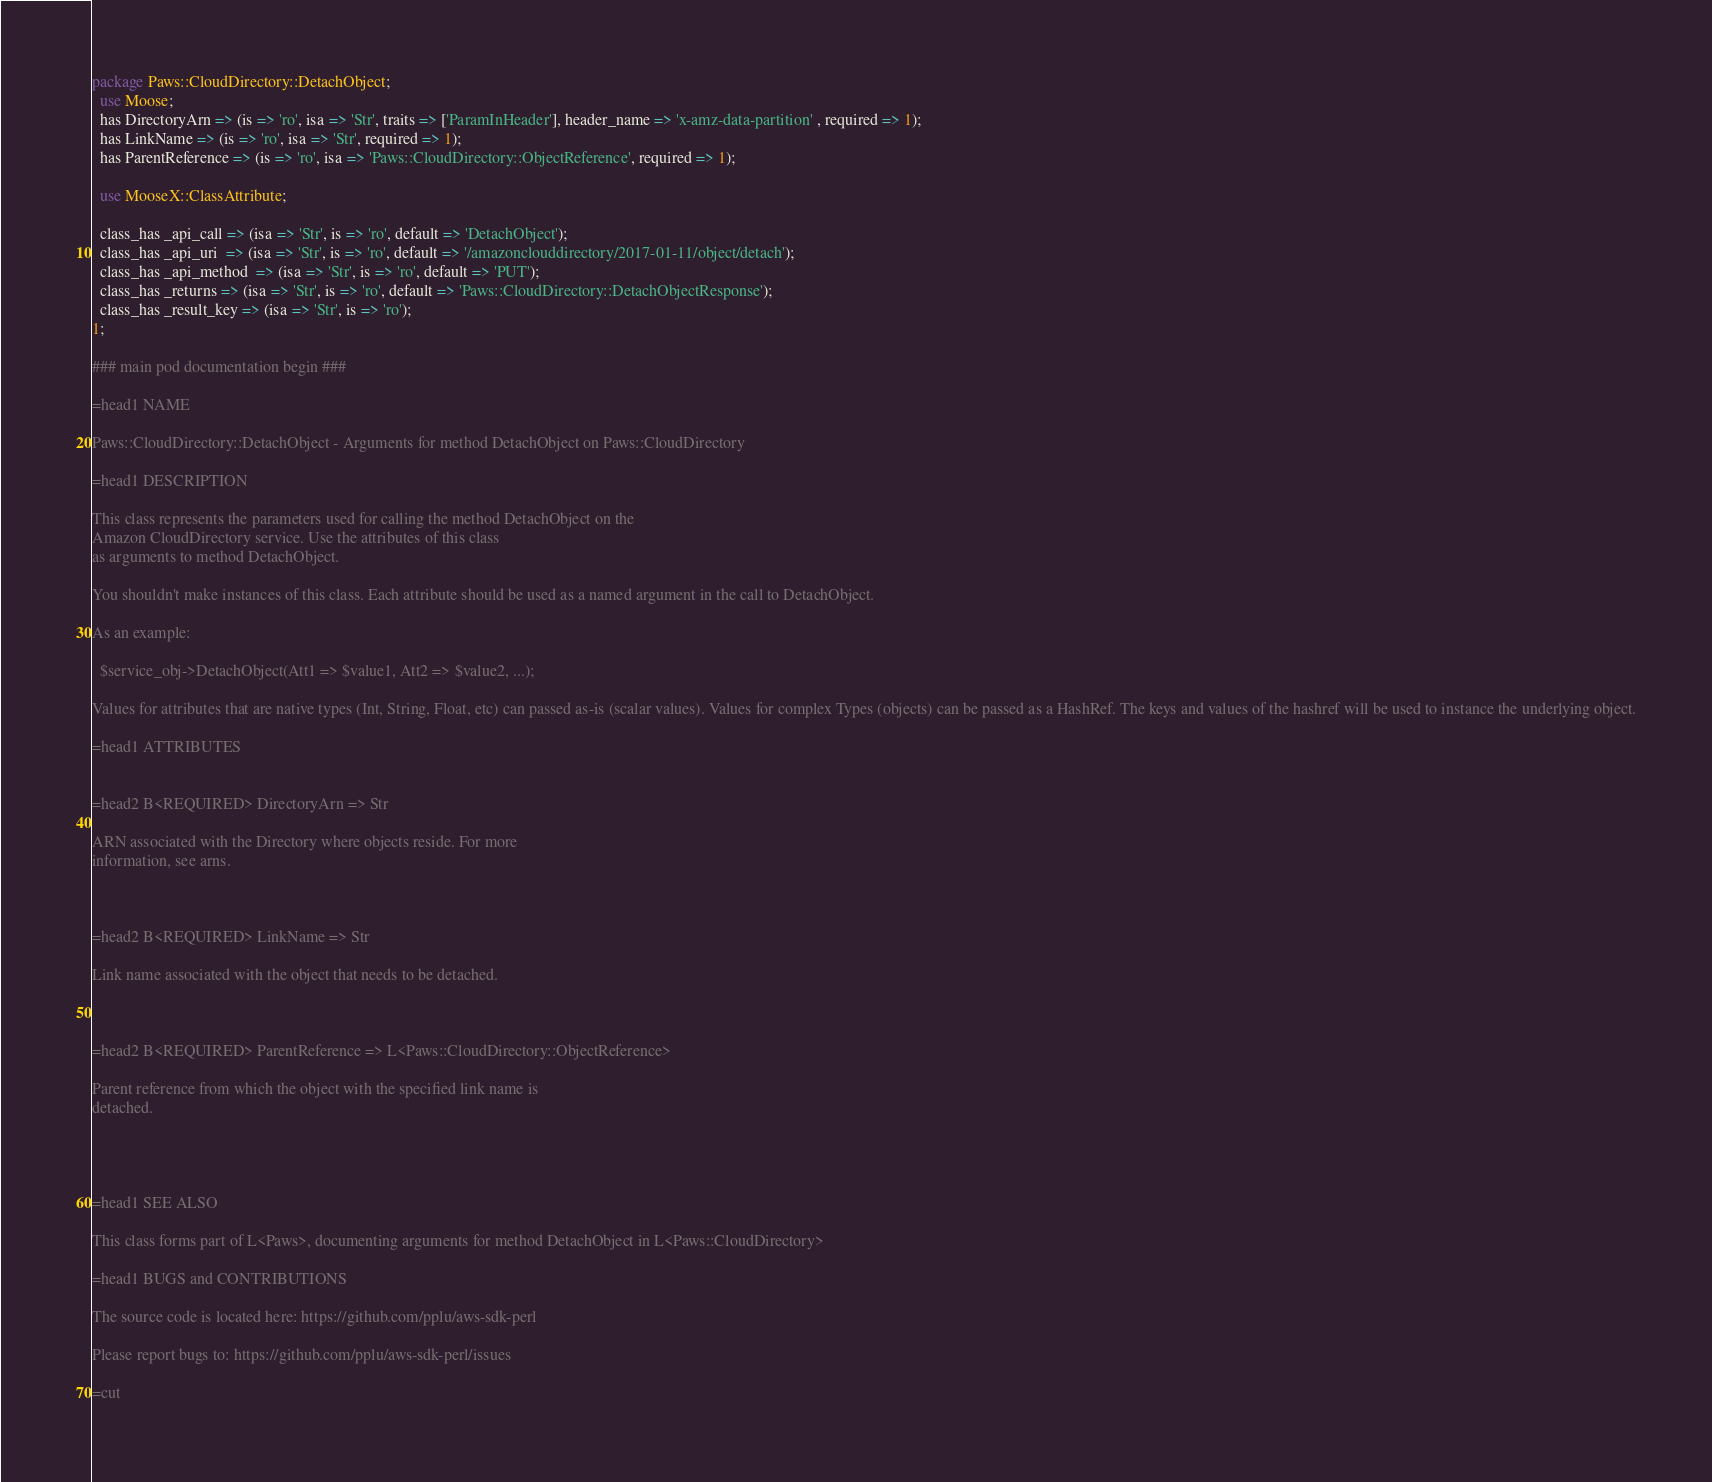<code> <loc_0><loc_0><loc_500><loc_500><_Perl_>package Paws::CloudDirectory::DetachObject;
  use Moose;
  has DirectoryArn => (is => 'ro', isa => 'Str', traits => ['ParamInHeader'], header_name => 'x-amz-data-partition' , required => 1);
  has LinkName => (is => 'ro', isa => 'Str', required => 1);
  has ParentReference => (is => 'ro', isa => 'Paws::CloudDirectory::ObjectReference', required => 1);

  use MooseX::ClassAttribute;

  class_has _api_call => (isa => 'Str', is => 'ro', default => 'DetachObject');
  class_has _api_uri  => (isa => 'Str', is => 'ro', default => '/amazonclouddirectory/2017-01-11/object/detach');
  class_has _api_method  => (isa => 'Str', is => 'ro', default => 'PUT');
  class_has _returns => (isa => 'Str', is => 'ro', default => 'Paws::CloudDirectory::DetachObjectResponse');
  class_has _result_key => (isa => 'Str', is => 'ro');
1;

### main pod documentation begin ###

=head1 NAME

Paws::CloudDirectory::DetachObject - Arguments for method DetachObject on Paws::CloudDirectory

=head1 DESCRIPTION

This class represents the parameters used for calling the method DetachObject on the 
Amazon CloudDirectory service. Use the attributes of this class
as arguments to method DetachObject.

You shouldn't make instances of this class. Each attribute should be used as a named argument in the call to DetachObject.

As an example:

  $service_obj->DetachObject(Att1 => $value1, Att2 => $value2, ...);

Values for attributes that are native types (Int, String, Float, etc) can passed as-is (scalar values). Values for complex Types (objects) can be passed as a HashRef. The keys and values of the hashref will be used to instance the underlying object.

=head1 ATTRIBUTES


=head2 B<REQUIRED> DirectoryArn => Str

ARN associated with the Directory where objects reside. For more
information, see arns.



=head2 B<REQUIRED> LinkName => Str

Link name associated with the object that needs to be detached.



=head2 B<REQUIRED> ParentReference => L<Paws::CloudDirectory::ObjectReference>

Parent reference from which the object with the specified link name is
detached.




=head1 SEE ALSO

This class forms part of L<Paws>, documenting arguments for method DetachObject in L<Paws::CloudDirectory>

=head1 BUGS and CONTRIBUTIONS

The source code is located here: https://github.com/pplu/aws-sdk-perl

Please report bugs to: https://github.com/pplu/aws-sdk-perl/issues

=cut

</code> 